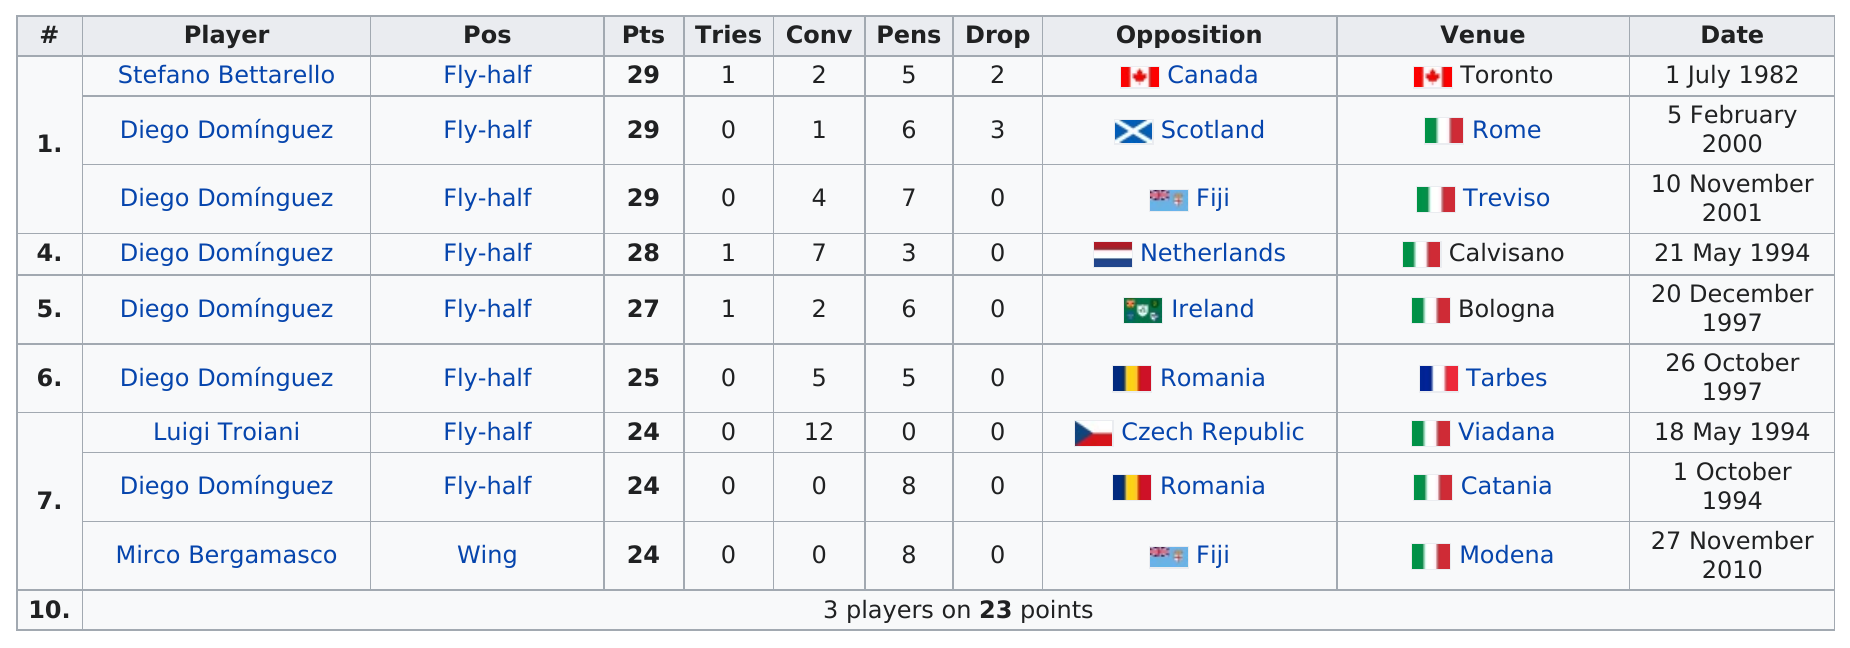Point out several critical features in this image. Out of the total number of players, how many scored at least 25 or more points? Diego Dominguez has 3 drops. In the history of Italian basketball players scoring at least 24 points, the fewest number of conversions scored by an Italian player is zero. The first player on the given list is Stefano Bettarello. Mirco Bergamasco is the only player who is not a fly-half, and thus stands out among his peers. 